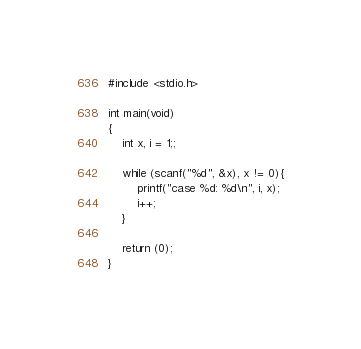Convert code to text. <code><loc_0><loc_0><loc_500><loc_500><_C_>#include <stdio.h>

int main(void)
{
	int x, i = 1;;
	
	while (scanf("%d", &x), x != 0){
		printf("case %d: %d\n", i, x);
		i++;
	}
	
	return (0);
}</code> 